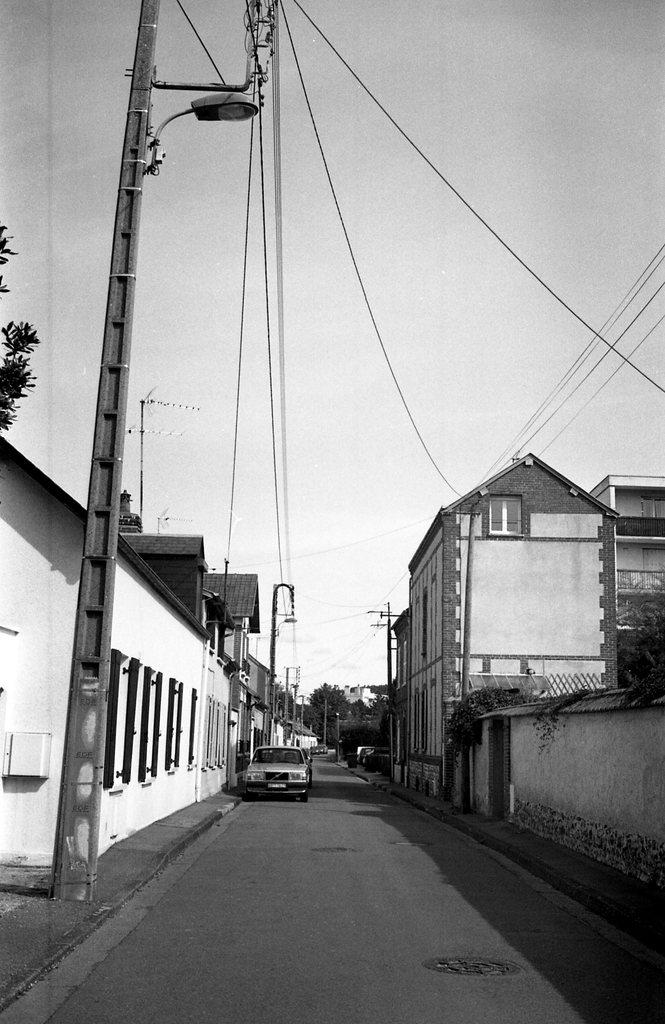What can be seen running through the image? There is a road visible in the image. What is on the road in the image? A vehicle is present on the road. What type of vegetation is beside the road? There are trees beside the road. What else is present in the air above the road? Power line cables are visible in the image. What is supporting the power line cables? A pole is present in the image. What is visible at the top of the image? The sky is visible at the top of the image. How many hands can be seen holding the harbor in the image? There is no harbor present in the image, and therefore no hands holding it. What type of connection can be seen between the power line cables and the pole in the image? The power line cables are connected to the pole through insulators, but there is no specific type of connection mentioned in the image. 